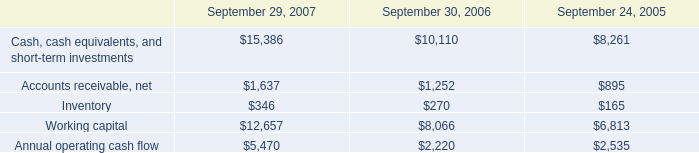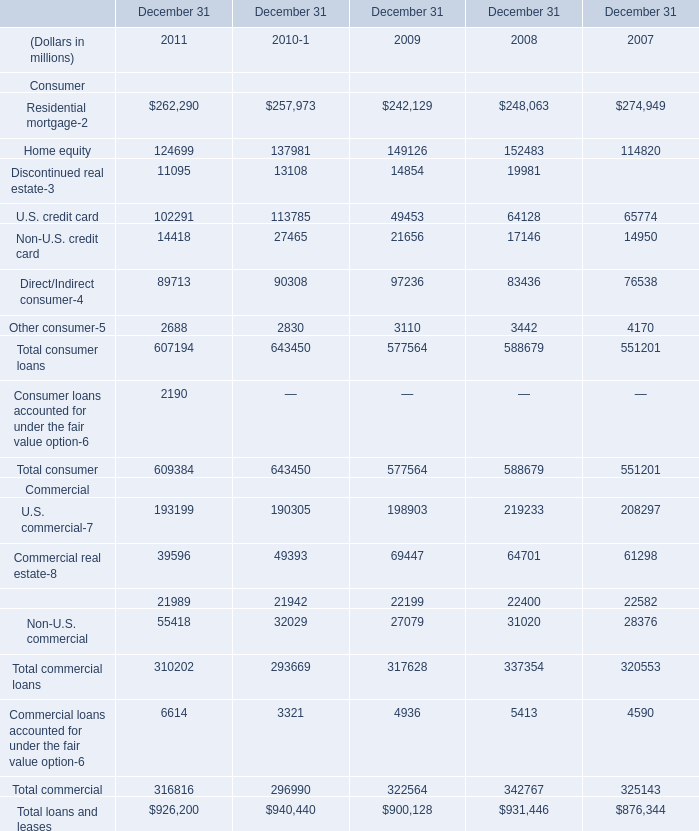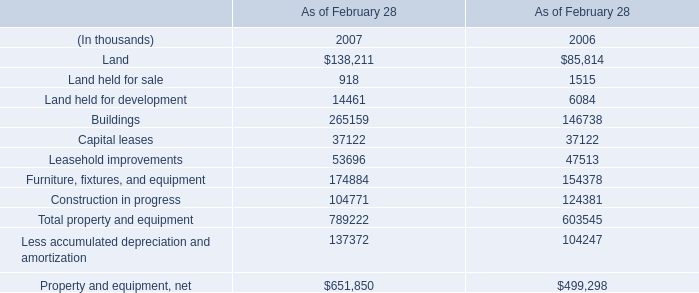what was the percentage change in inventory between 2005 and 2006? 
Computations: ((270 - 165) / 165)
Answer: 0.63636. 